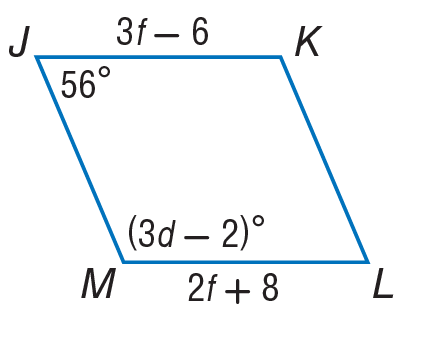Question: Find the value of d in the parallelogram.
Choices:
A. 42
B. 56
C. 84
D. 92
Answer with the letter. Answer: A Question: Find the value of f in the parallelogram.
Choices:
A. 14
B. 18
C. 36
D. 56
Answer with the letter. Answer: A 